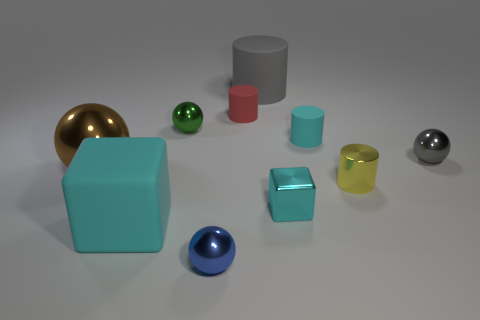What differentiates the golden sphere from the other objects in terms of appearance? The golden sphere stands out due to its highly reflective surface and distinct color, suggesting a glossy material finish unlike the more subdued and diffuse materials of the other objects. 